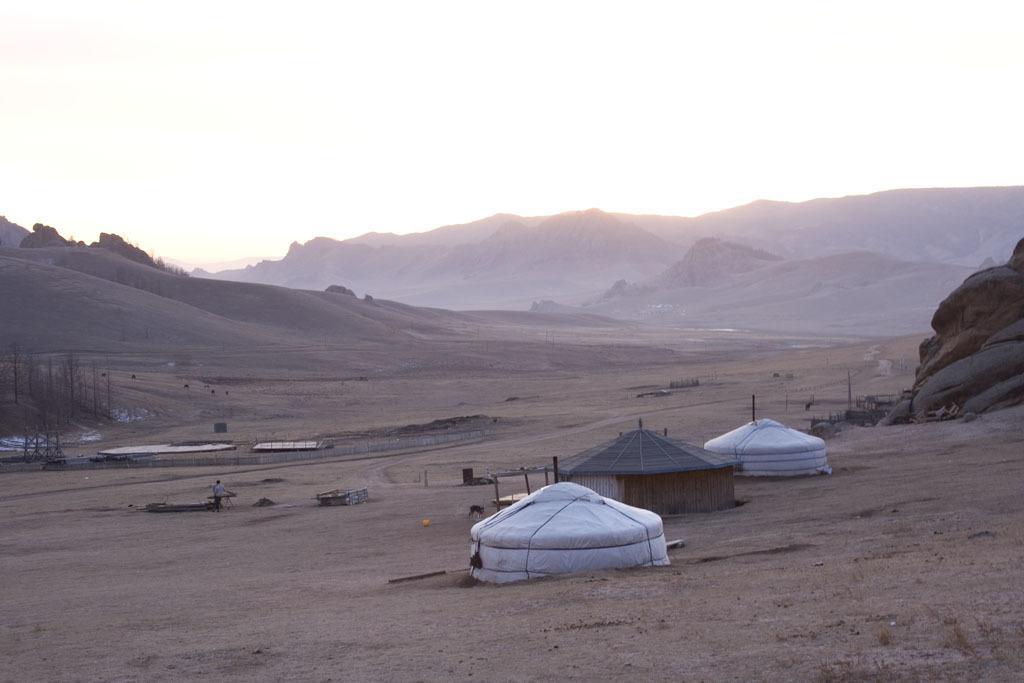Describe this image in one or two sentences. This picture might be taken outside city. In this image, in the middle, we can see three huts. On the right side, we can also see some stones. On the left side, we can see some trees and a person. In the background, we can see some trees, mountains. On the top, we can see a sky, at the bottom, we can see a land with some stones. 